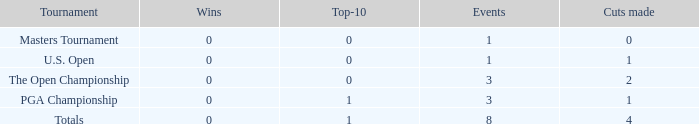For happenings with below 3 times engaged and lesser than 1 cut completed, what is the aggregate count of top-10 finishes? 1.0. 